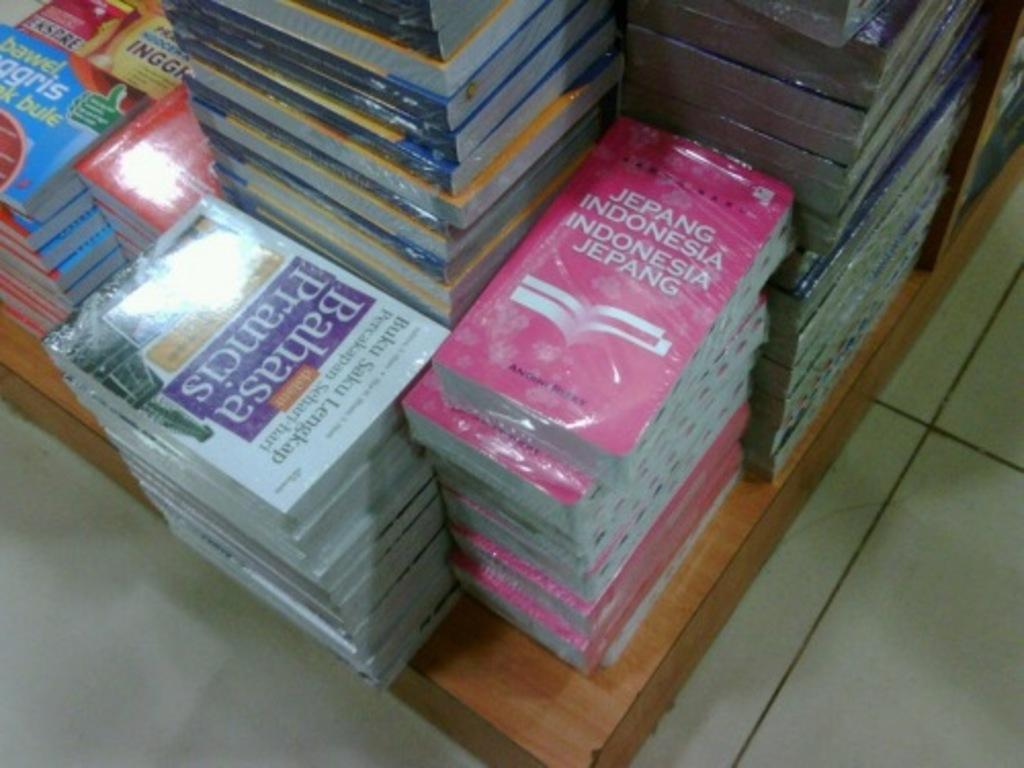Provide a one-sentence caption for the provided image. Jepang Indonnesia Indonesia Jepang is a red book. 